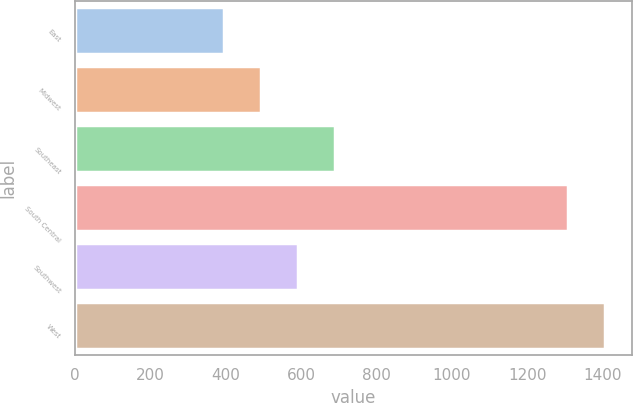<chart> <loc_0><loc_0><loc_500><loc_500><bar_chart><fcel>East<fcel>Midwest<fcel>Southeast<fcel>South Central<fcel>Southwest<fcel>West<nl><fcel>396.3<fcel>493.98<fcel>689.34<fcel>1308.8<fcel>591.66<fcel>1406.48<nl></chart> 